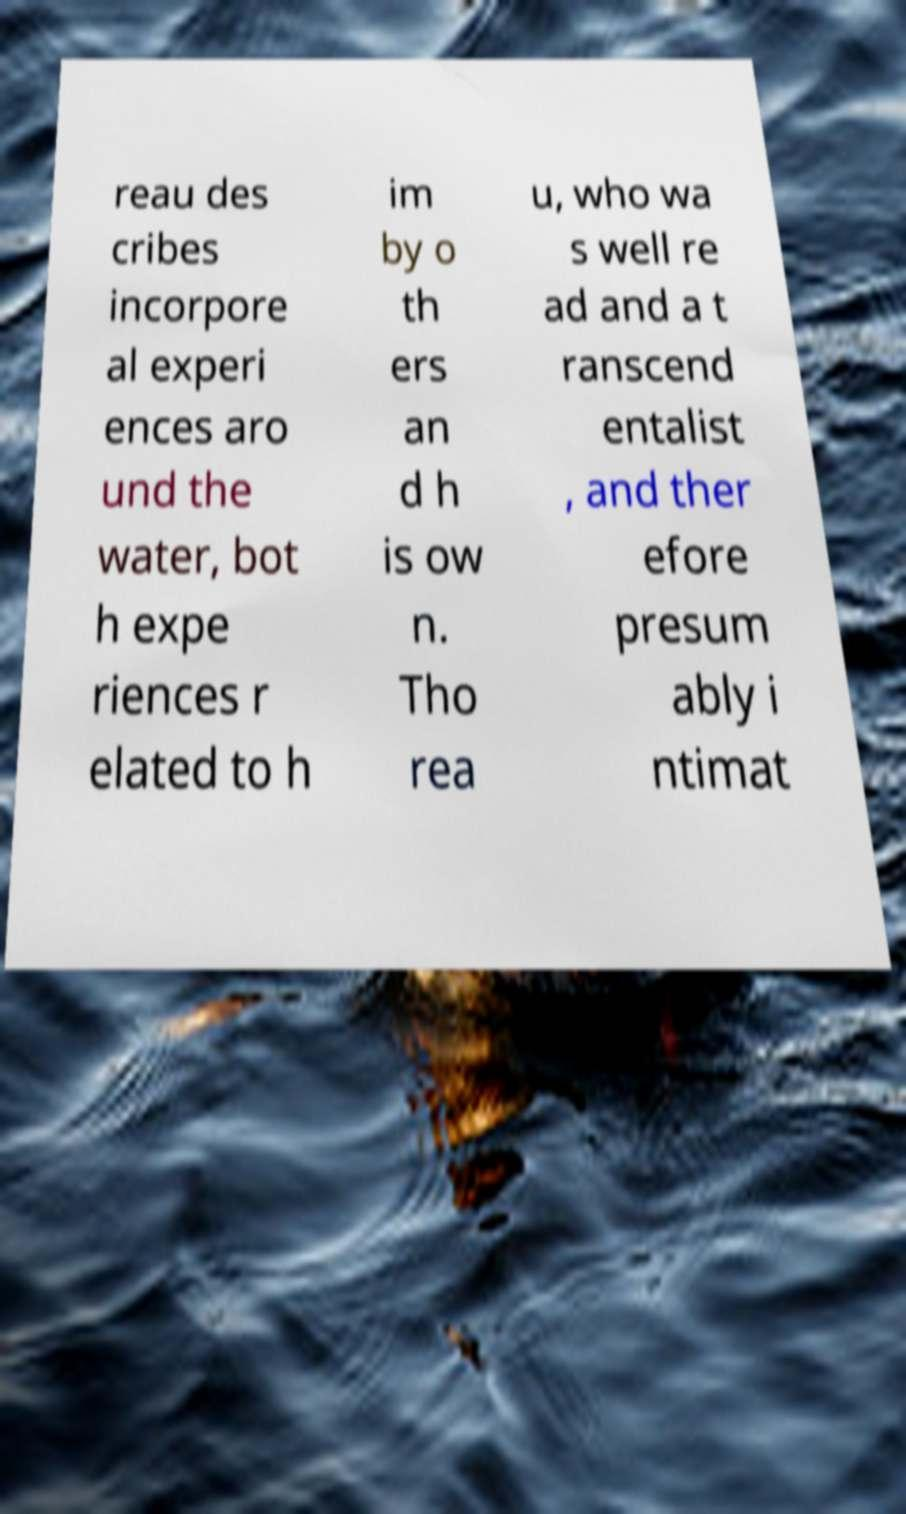Please read and relay the text visible in this image. What does it say? reau des cribes incorpore al experi ences aro und the water, bot h expe riences r elated to h im by o th ers an d h is ow n. Tho rea u, who wa s well re ad and a t ranscend entalist , and ther efore presum ably i ntimat 